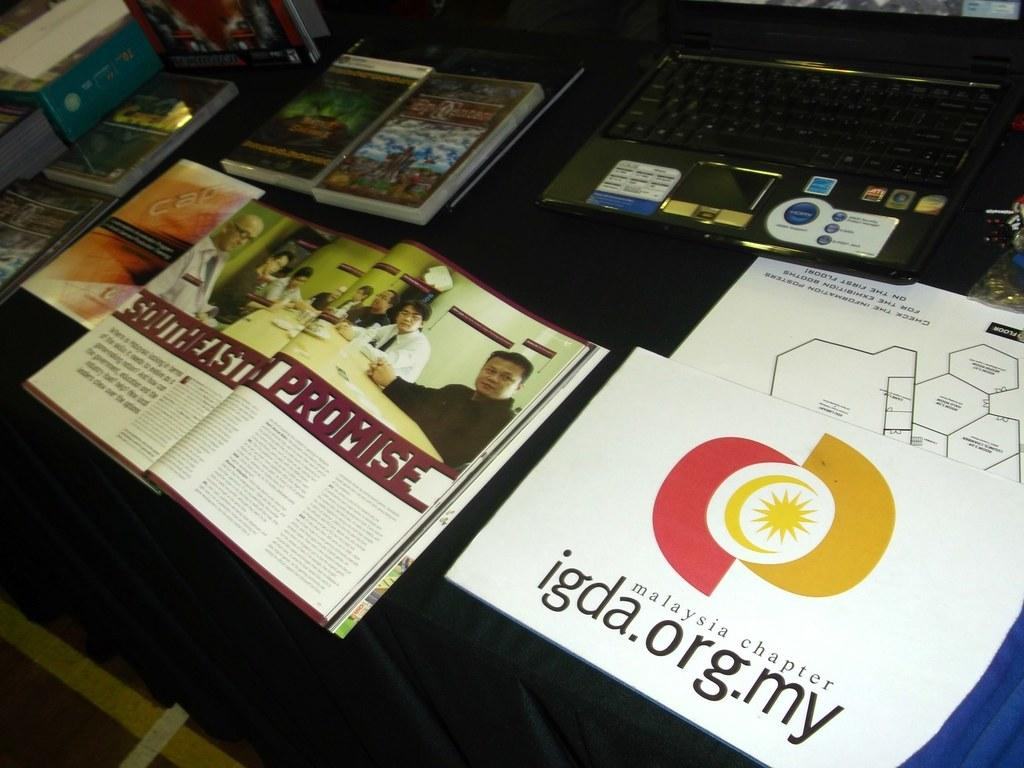<image>
Write a terse but informative summary of the picture. A table with a laptop, several various books, an open book depicting the Southeast Promise, and a Malaysia chapter igda.org.my booklet. 